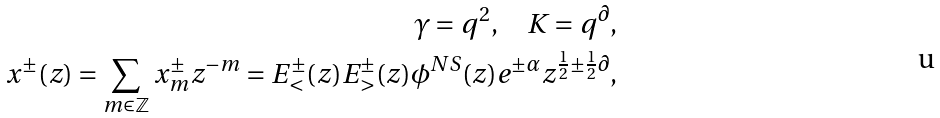<formula> <loc_0><loc_0><loc_500><loc_500>\gamma = q ^ { 2 } , \quad K = q ^ { \partial } , \\ x ^ { \pm } ( z ) = \sum _ { m \in \mathbb { Z } } x ^ { \pm } _ { m } z ^ { - m } = E ^ { \pm } _ { < } ( z ) E ^ { \pm } _ { > } ( z ) \phi ^ { N S } ( z ) e ^ { \pm \alpha } z ^ { \frac { 1 } { 2 } \pm \frac { 1 } { 2 } \partial } ,</formula> 